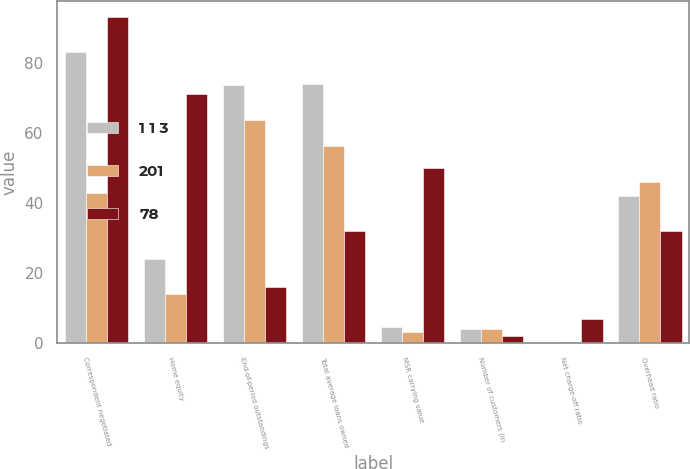Convert chart. <chart><loc_0><loc_0><loc_500><loc_500><stacked_bar_chart><ecel><fcel>Correspondent negotiated<fcel>Home equity<fcel>End-of-period outstandings<fcel>Total average loans owned<fcel>MSR carrying value<fcel>Number of customers (in<fcel>Net charge-off ratio<fcel>Overhead ratio<nl><fcel>1 1 3<fcel>83<fcel>24<fcel>73.7<fcel>74.1<fcel>4.8<fcel>4.1<fcel>0.18<fcel>42<nl><fcel>201<fcel>43<fcel>14<fcel>63.6<fcel>56.2<fcel>3.2<fcel>4<fcel>0.25<fcel>46<nl><fcel>78<fcel>93<fcel>71<fcel>16<fcel>32<fcel>50<fcel>2<fcel>7<fcel>32<nl></chart> 